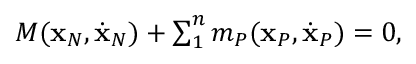Convert formula to latex. <formula><loc_0><loc_0><loc_500><loc_500>\begin{array} { r } { M ( { x } _ { N } , \dot { x } _ { N } ) + \sum _ { 1 } ^ { n } m _ { P } ( { x } _ { P } , \dot { x } _ { P } ) = 0 , } \end{array}</formula> 